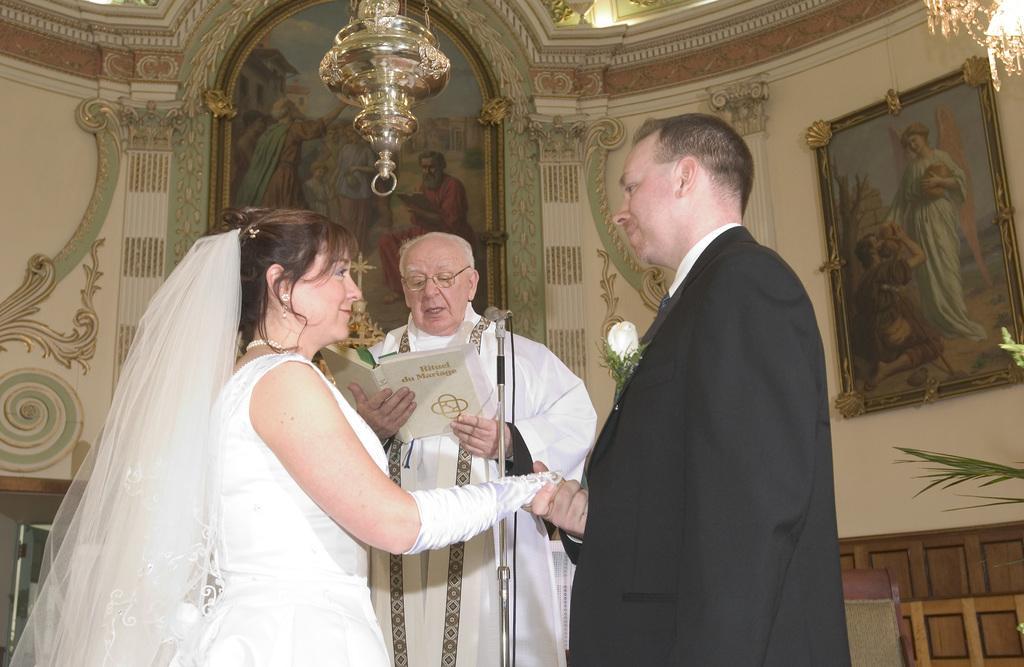In one or two sentences, can you explain what this image depicts? This image might be clicked in a church. There are three persons in this image. One is woman, two are men. There are so many photo frames in this image. There is light at the top. 